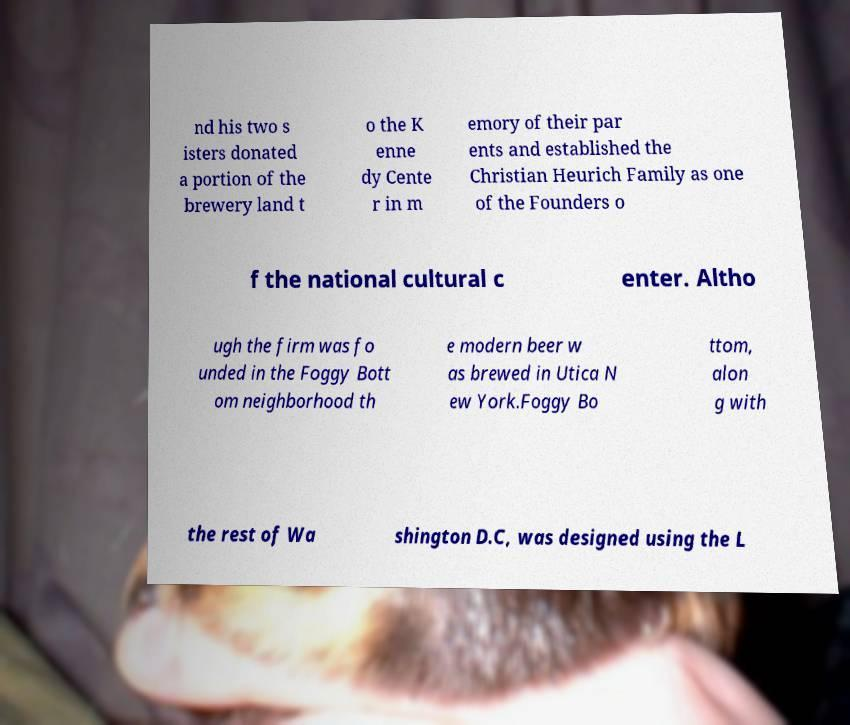What messages or text are displayed in this image? I need them in a readable, typed format. nd his two s isters donated a portion of the brewery land t o the K enne dy Cente r in m emory of their par ents and established the Christian Heurich Family as one of the Founders o f the national cultural c enter. Altho ugh the firm was fo unded in the Foggy Bott om neighborhood th e modern beer w as brewed in Utica N ew York.Foggy Bo ttom, alon g with the rest of Wa shington D.C, was designed using the L 